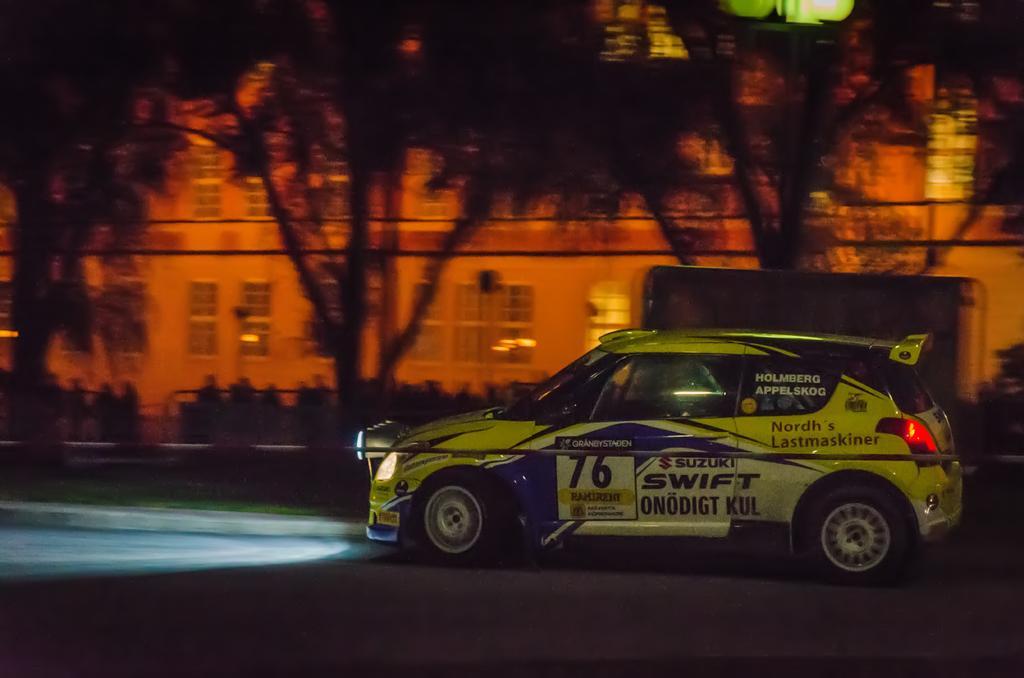Describe this image in one or two sentences. On the right side, there is a vehicle on a road. In the background, there are trees, plants and a building which is having windows. 